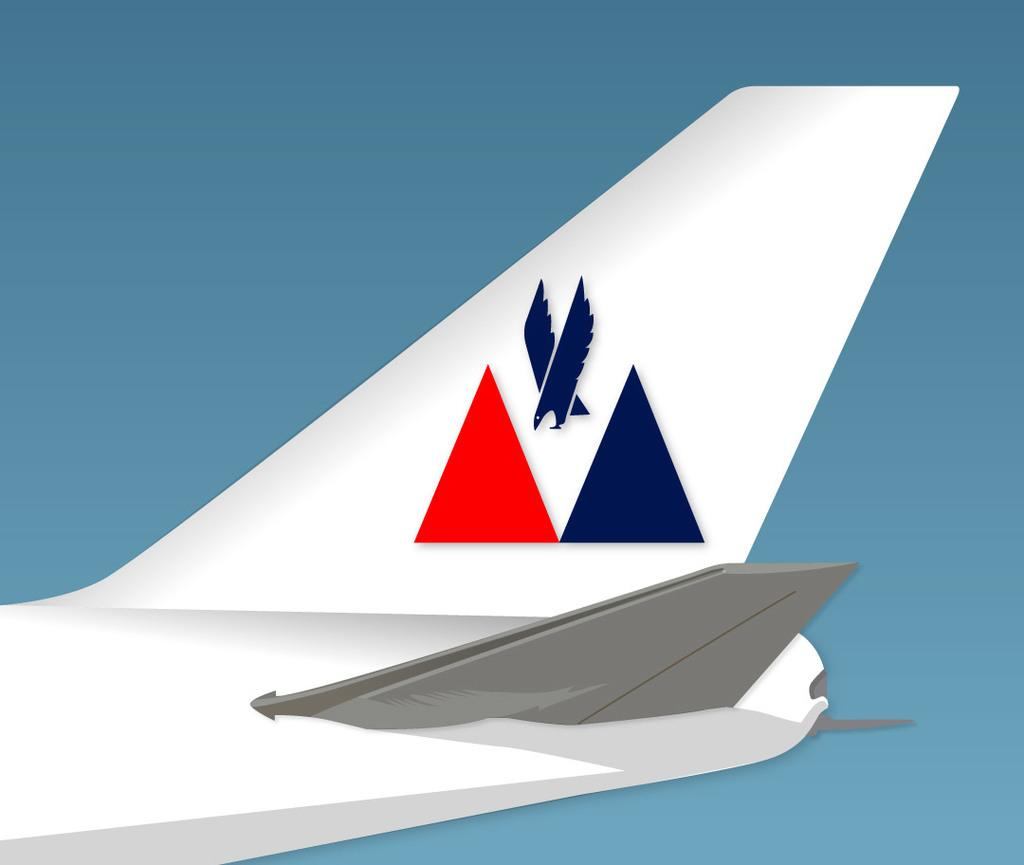What type of image is being described? The image is an animation. What is the main subject of the animation? There is an aeroplane in the image. What is the aeroplane doing in the animation? The aeroplane is flying in the sky. What type of advertisement can be seen on the side of the aeroplane in the image? There is no advertisement visible on the side of the aeroplane in the image. Can you tell me how many sticks are being held by the grandmother in the image? There is no grandmother or sticks present in the image. 